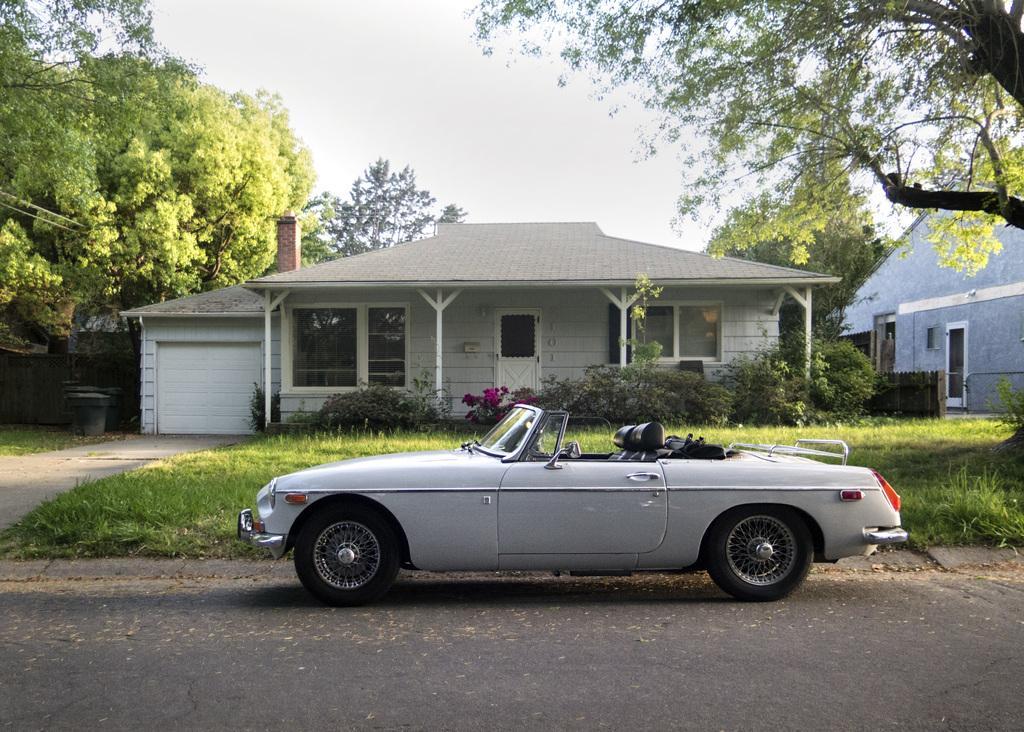In one or two sentences, can you explain what this image depicts? In this image I can see few buildings, windows, doors, trees, plants and the vehicle on the road. The sky is in white color. 